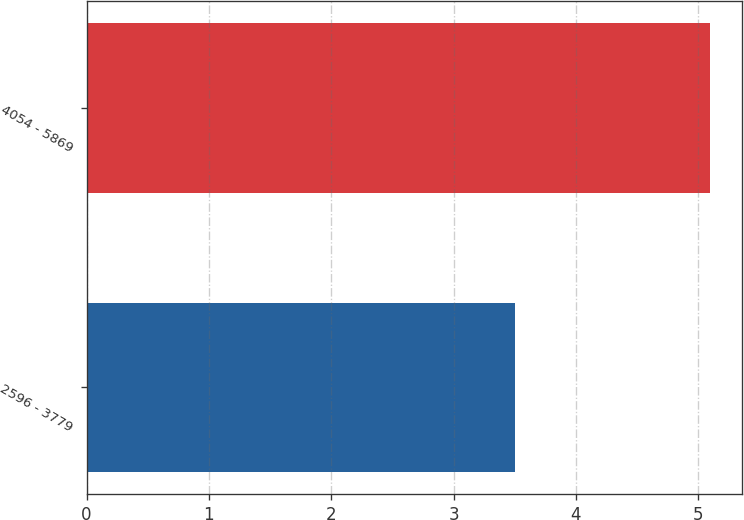<chart> <loc_0><loc_0><loc_500><loc_500><bar_chart><fcel>2596 - 3779<fcel>4054 - 5869<nl><fcel>3.5<fcel>5.1<nl></chart> 